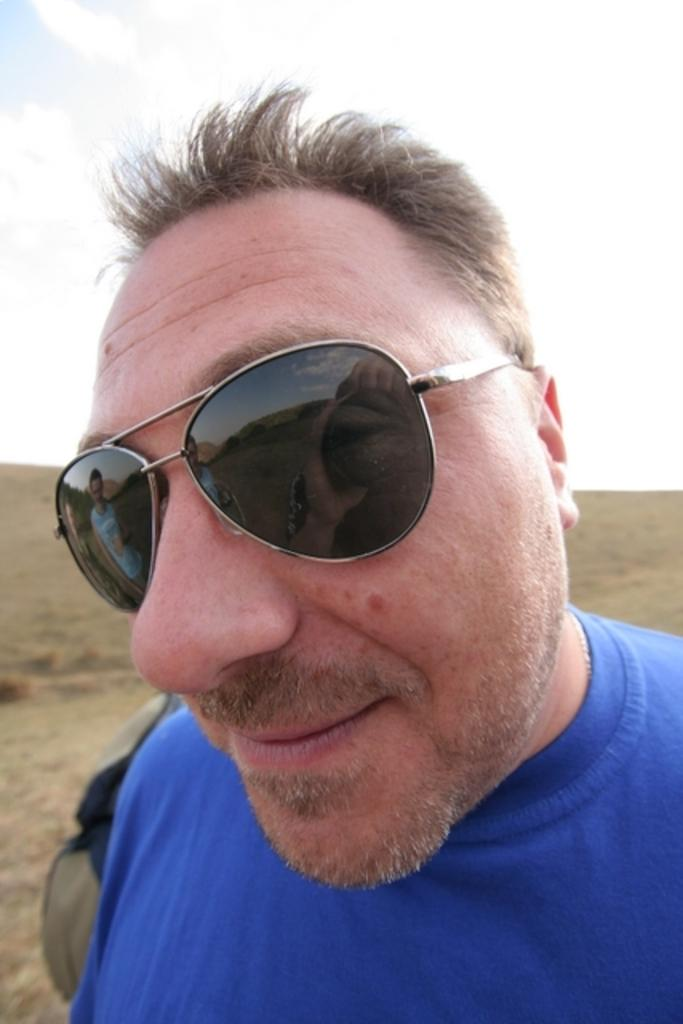Who is the main subject in the image? There is a man in the center of the image. What is the man wearing in the image? The man is wearing glasses in the image. What can be seen in the background of the image? There appears to be a bag in the background, and the sky is also visible. How would you describe the overall appearance of the image? The image has a muddy texture. What type of cast can be seen on the man's arm in the image? There is no cast visible on the man's arm in the image. What level of detail can be seen on the carriage in the image? There is no carriage present in the image. 